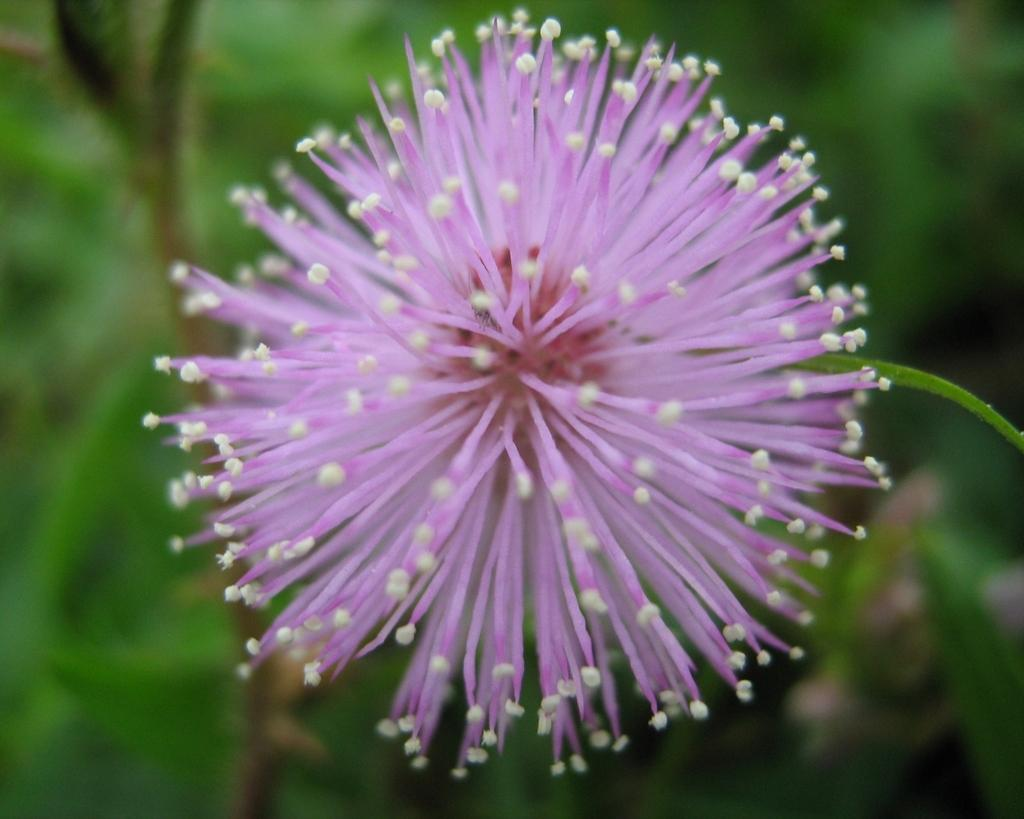Where was the image taken? The image was taken outdoors. What can be seen in the background of the image? There are plants in the background of the image. What is the main subject of the image? There is a beautiful flower in the middle of the image. What color is the flower? The flower is lilac in color. Is there a trail leading up to the mountain in the image? There is no trail or mountain present in the image; it features a beautiful lilac flower in the foreground and plants in the background. 